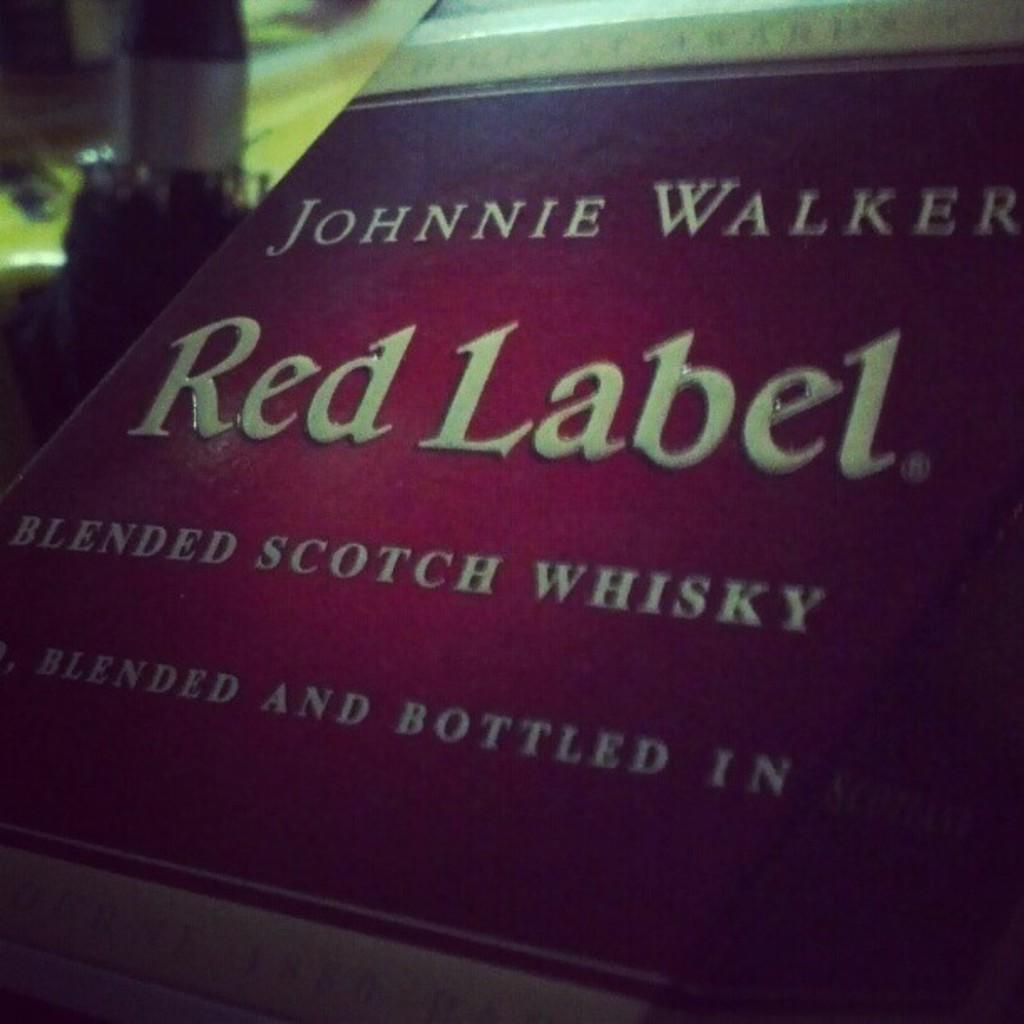<image>
Write a terse but informative summary of the picture. Scotch whisky has a red label with white lettering. 